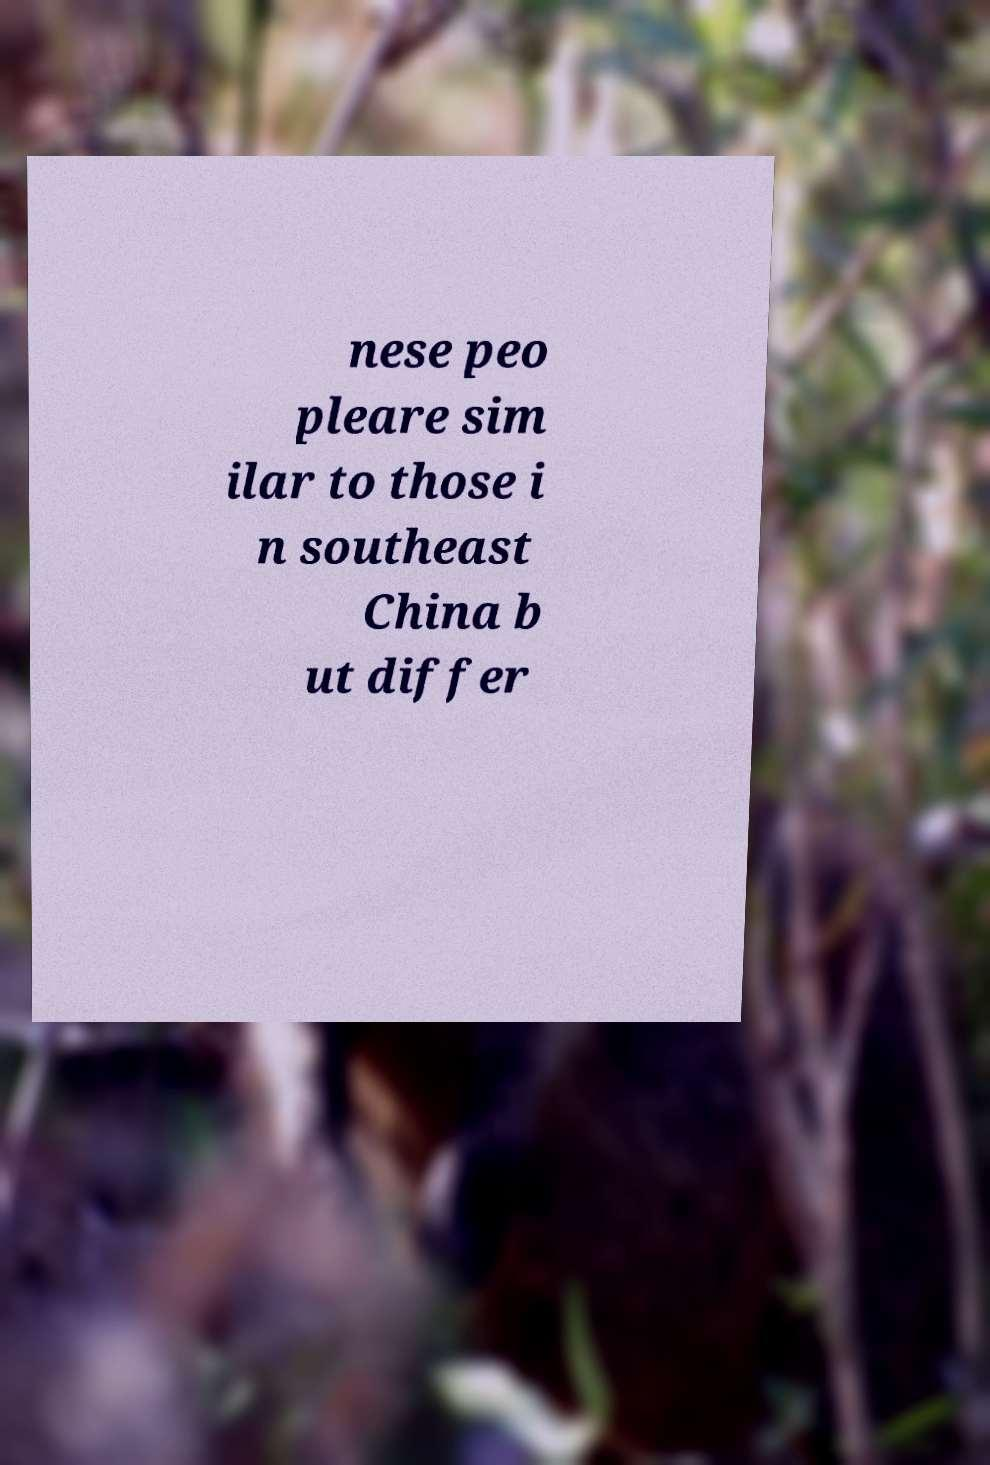Can you accurately transcribe the text from the provided image for me? nese peo pleare sim ilar to those i n southeast China b ut differ 